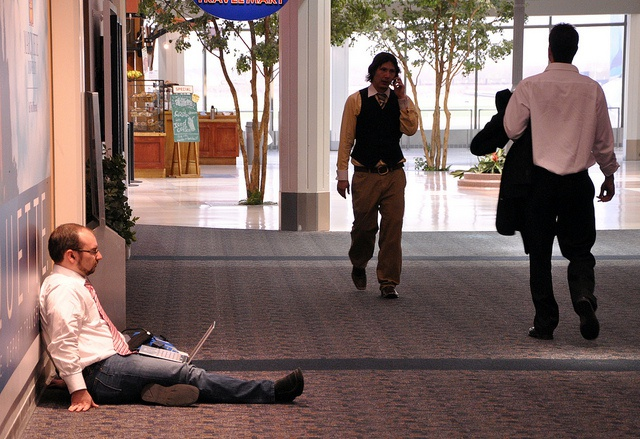Describe the objects in this image and their specific colors. I can see people in lightpink, black, gray, brown, and darkgray tones, people in lightpink, black, white, and maroon tones, people in lightpink, black, maroon, white, and gray tones, potted plant in lightpink, black, gray, and maroon tones, and laptop in lightpink, pink, gray, and brown tones in this image. 